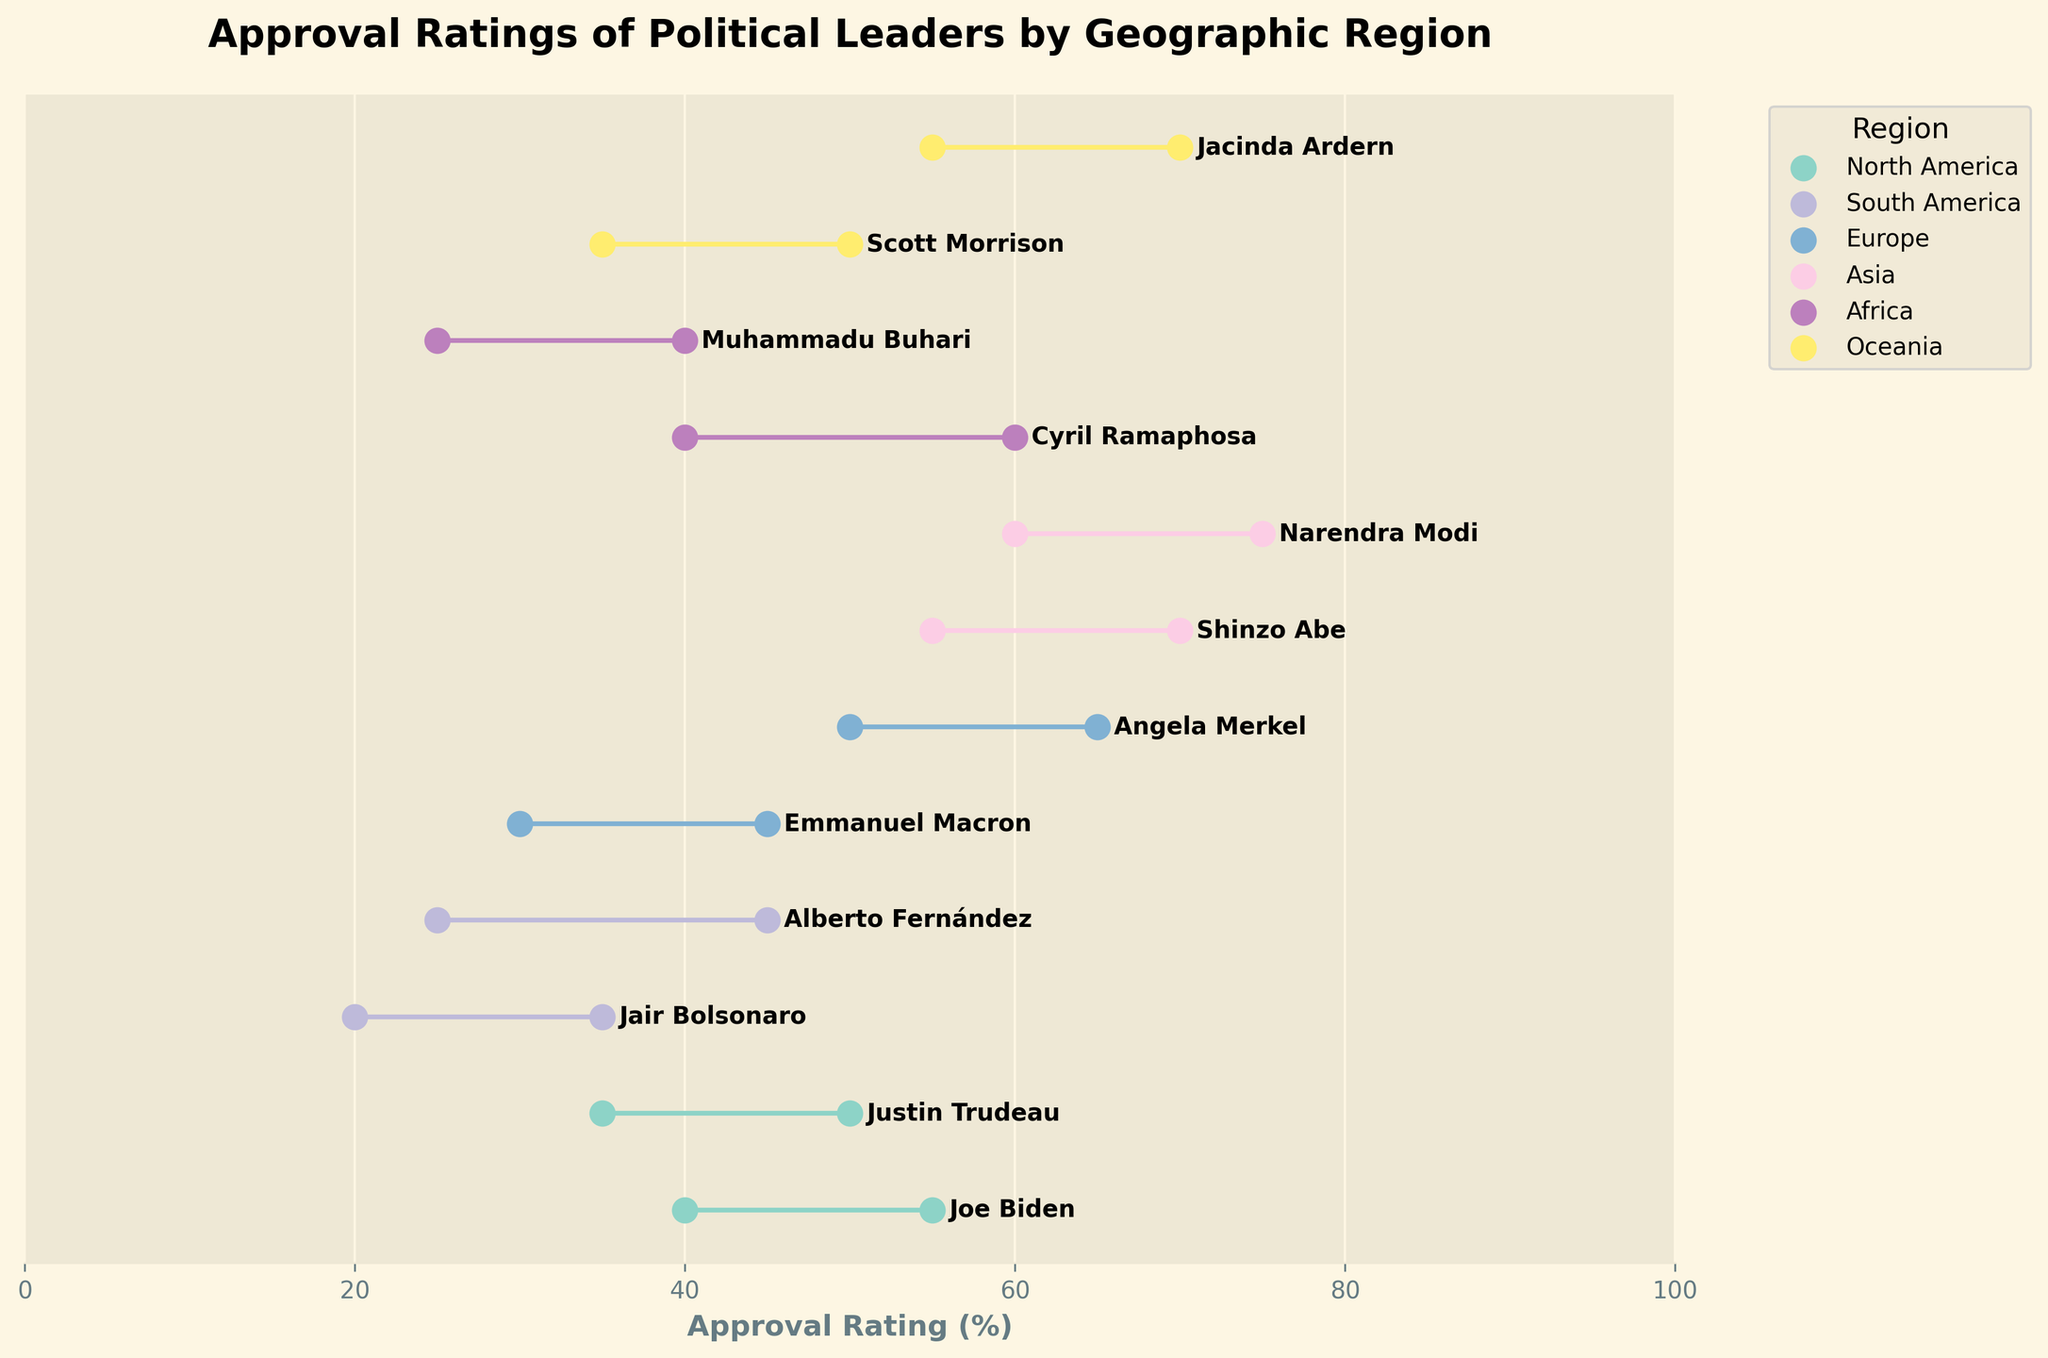What's the maximum approval rating for a political leader from North America? The title "Approval Ratings of Political Leaders by Geographic Region" suggests that the regions, including North America, are on the plot. Joe Biden and Justin Trudeau represent North America. The maximum approval ratings for Joe Biden and Justin Trudeau are both plotted, and among them, the highest value is 55 (Joe Biden).
Answer: 55 What's the average minimum approval rating for African leaders? The two African leaders are Cyril Ramaphosa and Muhammadu Buhari. Their minimum approval ratings are 40 and 25 respectively. The average is calculated as (40 + 25) / 2.
Answer: 32.5 Who has a higher maximum approval rating: Angela Merkel or Shinzo Abe? From the plot, Angela Merkel's maximum approval rating is 65, and Shinzo Abe's maximum approval rating is 70.
Answer: Shinzo Abe What is the range difference in approval ratings between Justin Trudeau and Jair Bolsonaro? Justin Trudeau's range is from 35 to 50 (which is 15) and Jair Bolsonaro's is from 20 to 35 (which is also 15). The difference in their ranges is 0 (15 - 15).
Answer: 0 Which leader has the smallest gap between their minimum and maximum approval ratings? Observing the ranges for all leaders: Joe Biden (15), Justin Trudeau (15), Jair Bolsonaro (15), Alberto Fernández (20), Emmanuel Macron (15), Angela Merkel (15), Shinzo Abe (15), Narendra Modi (15), Cyril Ramaphosa (20), Muhammadu Buhari (15), Scott Morrison (15), Jacinda Ardern (15). Jair Bolsonaro is one of the leaders tied for the smallest gap of 15.
Answer: Jair Bolsonaro (among others) What is the title of the figure? The title is typically placed at the top of the plot. In this figure, it reads: "Approval Ratings of Political Leaders by Geographic Region".
Answer: Approval Ratings of Political Leaders by Geographic Region Which region has the leader with the highest minimum approval rating? Looking at the minimum approval ratings, Shinzo Abe from Asia has the highest minimum approval rating at 55.
Answer: Asia What is the combined range (min to max) of approval ratings for South American leaders? Jair Bolsonaro's range is 20 to 35, and Alberto Fernández's range is 25 to 45. The combined range spans from the minimum value of Jair Bolsonaro (20) to the maximum value of Alberto Fernández (45).
Answer: 20-45 How many political leaders from Europe are included in the figure? From the plot, Europe is represented by two leaders: Emmanuel Macron and Angela Merkel.
Answer: 2 Who has a higher minimum approval rating: Cyril Ramaphosa or Scott Morrison? Cyril Ramaphosa's minimum rating is 40 while Scott Morrison's minimum rating is 35.
Answer: Cyril Ramaphosa 